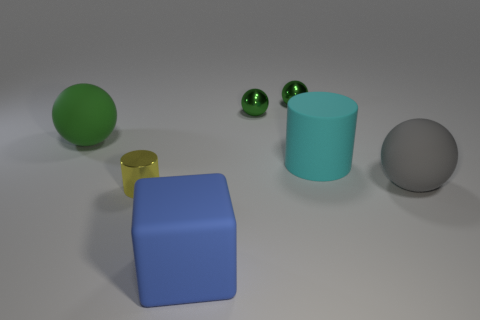Is there any other thing that has the same size as the gray rubber thing?
Your answer should be compact. Yes. Are there fewer green matte things that are on the right side of the gray thing than matte things that are right of the large blue cube?
Give a very brief answer. Yes. How many other things are there of the same shape as the blue matte thing?
Offer a terse response. 0. What size is the matte ball right of the small shiny thing that is in front of the large rubber sphere that is to the right of the tiny yellow cylinder?
Your response must be concise. Large. How many blue things are either rubber cylinders or balls?
Offer a terse response. 0. What shape is the green object that is on the left side of the large object that is in front of the small yellow metal cylinder?
Your answer should be compact. Sphere. There is a metal object that is in front of the green matte thing; does it have the same size as the thing left of the small cylinder?
Your answer should be very brief. No. Are there any big spheres made of the same material as the blue object?
Your answer should be very brief. Yes. Are there any big rubber balls that are on the right side of the big ball to the right of the metal thing on the left side of the large blue rubber object?
Your answer should be very brief. No. Are there any cylinders in front of the blue matte thing?
Make the answer very short. No. 